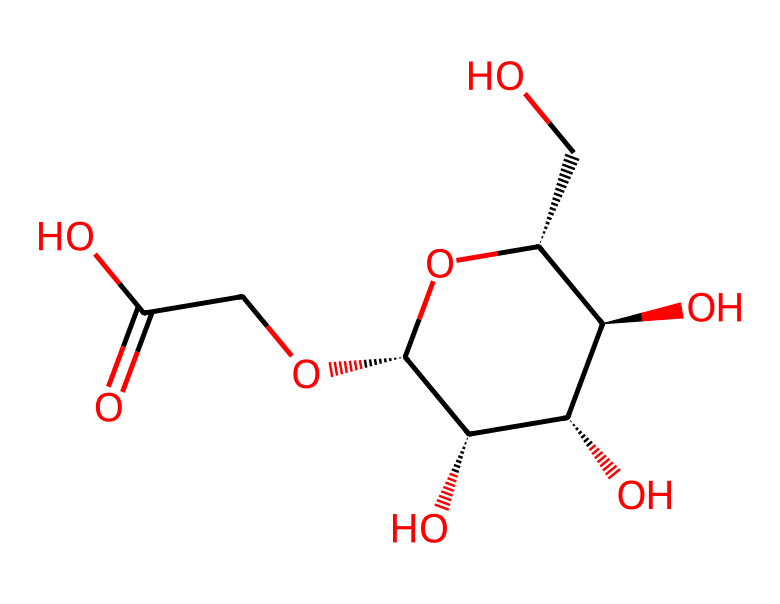what is the molecular formula of carboxymethyl cellulose? To find the molecular formula, count the number of carbon, hydrogen, and oxygen atoms in the chemical structure represented by the SMILES. In this case, there are 8 carbon atoms, 14 hydrogen atoms, and 8 oxygen atoms. Therefore, the molecular formula is: C8H14O8.
Answer: C8H14O8 how many hydroxyl groups are present in this structure? By analyzing the chemical structure, look for -OH (hydroxyl) groups. In this specific structure, there are 4 -OH groups present, which are indicated by the carbon atoms that are connected to hydroxyl groups.
Answer: 4 what type of linkage is present in carboxymethyl cellulose? This compound has ether and ester linkages. Ether linkages are seen in the ether functional groups attaching hydrocarbon chains to the cellulose backbone, while ester linkages are formed from the carboxymethyl group.
Answer: ether and ester how does the presence of carboxymethyl groups affect the viscosity of the solution? The addition of carboxymethyl groups increases the hydrophilicity of the polymer, leading to enhanced interactions with water and a significant increase in viscosity when dissolved. This indicates that non-Newtonian fluids can exhibit shear-thinning behavior due to the long-range interactions in the solution.
Answer: increases viscosity is carboxymethyl cellulose soluble in water? Based on its structure, which includes multiple hydroxyl groups and carboxymethyl substitutions, this polymer is hydrophilic and thus readily soluble in water.
Answer: yes what type of polymer is carboxymethyl cellulose? Carboxymethyl cellulose is a polysaccharide, specifically a modified cellulose derivative that consists of repeating glucose units with carboxymethyl substitutions.
Answer: polysaccharide does carboxymethyl cellulose exhibit shear-thinning properties? Given its non-Newtonian fluid characteristics, carboxymethyl cellulose exhibits shear-thinning behavior, which means that its viscosity decreases under shear stress, making it easier to apply in formulations.
Answer: yes 